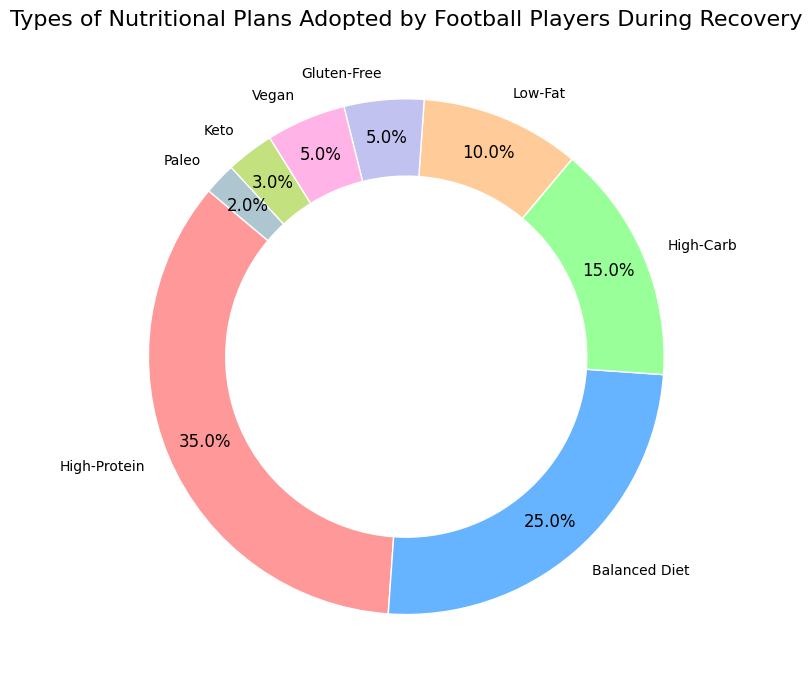Which nutritional plan is adopted by the highest percentage of football players? The largest section in the pie chart represents the High-Protein plan, which clearly occupies the most space indicating the highest percentage.
Answer: High-Protein What is the combined percentage of players adopting Vegan and Gluten-Free plans? Add the percentages of the Vegan (5%) and Gluten-Free (5%) plans: 5% + 5% = 10%.
Answer: 10% How does the percentage of players on a Balanced Diet compare to those on a High-Carb plan? The pie chart shows that the Balanced Diet is 25% while the High-Carb plan is 15%. Therefore, the Balanced Diet percentage is higher.
Answer: Balanced Diet higher Which nutritional plan is adopted by the smallest percentage of players? The smallest section in the pie chart is labeled Paleo, which occupies the smallest space indicating the smallest percentage.
Answer: Paleo What is the total percentage of players adopting Low-Fat, Gluten-Free, and Keto plans? Add the percentages: Low-Fat (10%) + Gluten-Free (5%) + Keto (3%): 10% + 5% + 3% = 18%.
Answer: 18% Among High-Protein, Balanced Diet, and Low-Fat plans, which has the least adoption percentage? Compare the percentages: High-Protein (35%), Balanced Diet (25%), and Low-Fat (10%). The Low-Fat plan has the smallest percentage among these.
Answer: Low-Fat What is the difference in percentage between High-Protein and Keto plans? Subtract the percentage of the Keto plan (3%) from the High-Protein plan (35%): 35% - 3% = 32%.
Answer: 32% How much more popular is the High-Protein plan compared to the Balanced Diet? Subtract the percentage of the Balanced Diet (25%) from the High-Protein plan (35%): 35% - 25% = 10%.
Answer: 10% What percentage of players are on plans other than High-Protein, Balanced Diet, or High-Carb? Sum the percentages of all other plans: Low-Fat (10%) + Gluten-Free (5%) + Vegan (5%) + Keto (3%) + Paleo (2%): 10% + 5% + 5% + 3% + 2% = 25%.
Answer: 25% Which plan(s) make up more than 20% of the nutritional plans adopted by football players? The High-Protein plan (35%) and the Balanced Diet (25%) both make up more than 20% according to the pie chart.
Answer: High-Protein, Balanced Diet 